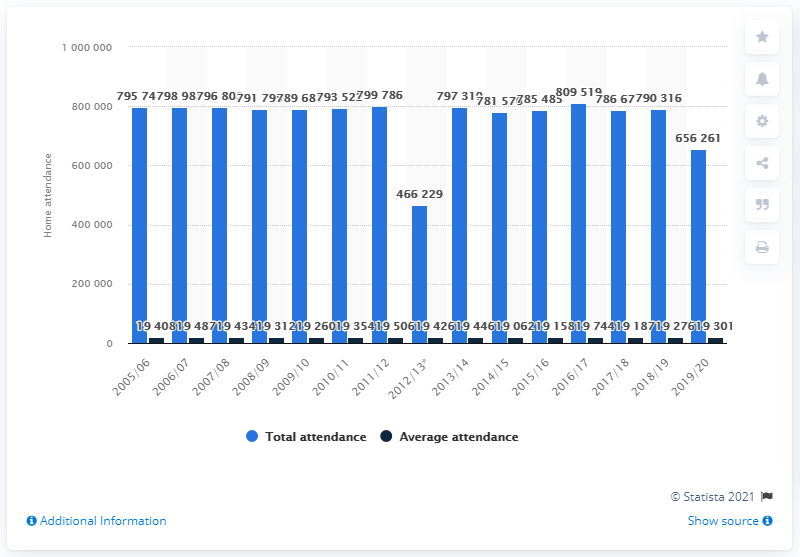Give some essential details in this illustration. The Toronto Maple Leafs franchise was active during the 2005/2006 season. 